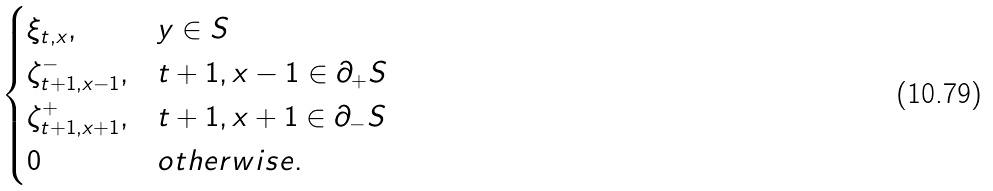<formula> <loc_0><loc_0><loc_500><loc_500>\begin{cases} \xi _ { t , x } , & y \in S \\ \zeta ^ { - } _ { t + 1 , x - 1 } , & t + 1 , x - 1 \in \partial _ { + } S \\ \zeta ^ { + } _ { t + 1 , x + 1 } , & t + 1 , x + 1 \in \partial _ { - } S \\ 0 & o t h e r w i s e . \end{cases}</formula> 